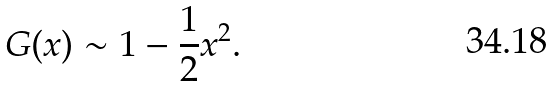<formula> <loc_0><loc_0><loc_500><loc_500>G ( x ) \sim 1 - \frac { 1 } { 2 } x ^ { 2 } .</formula> 